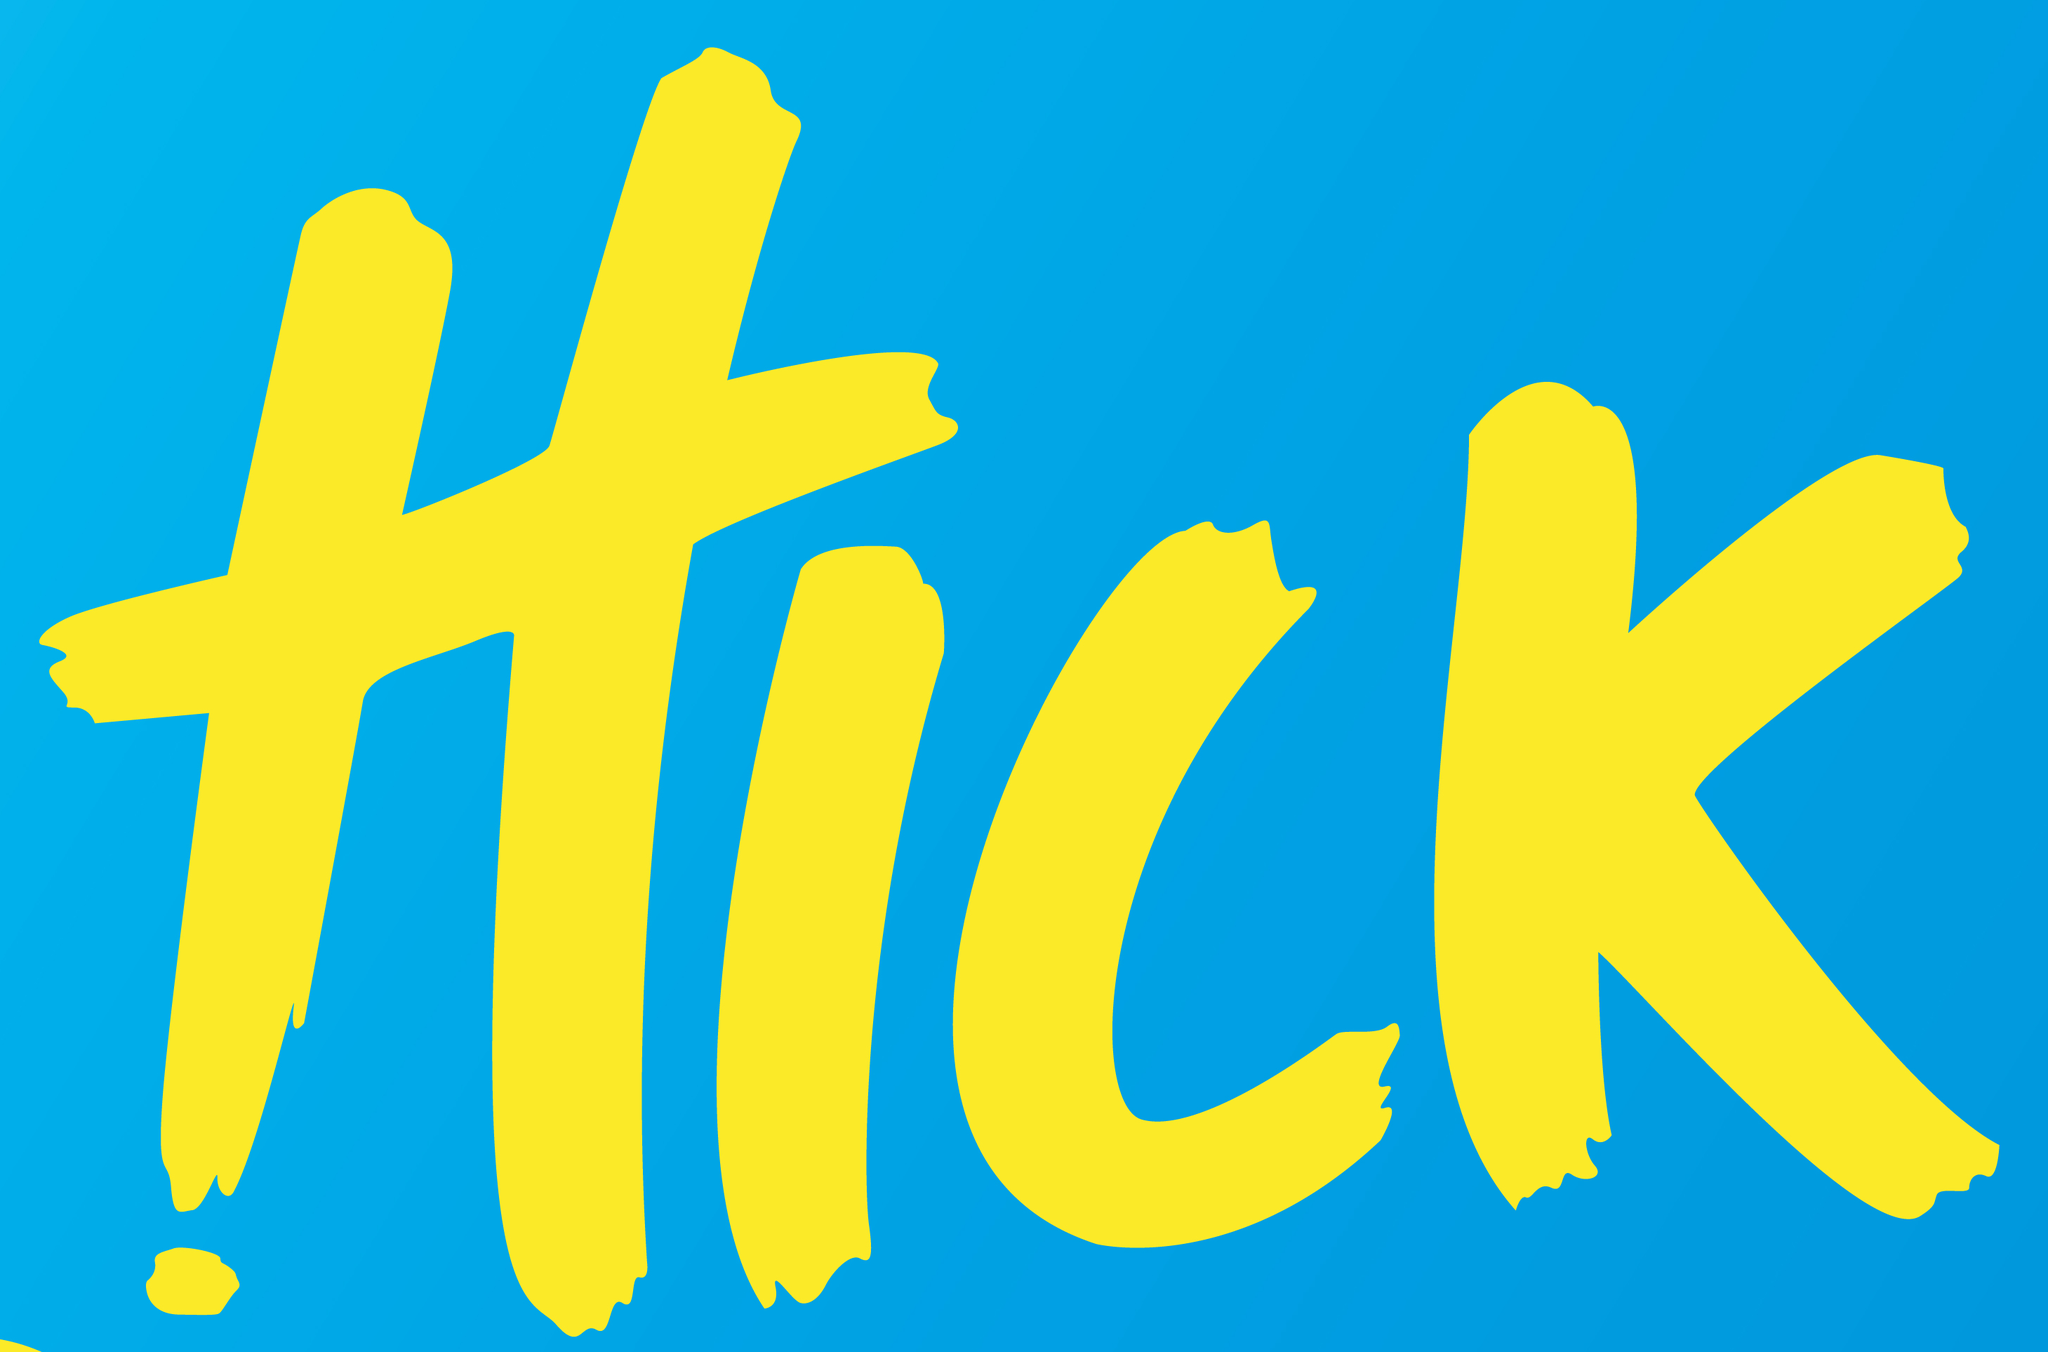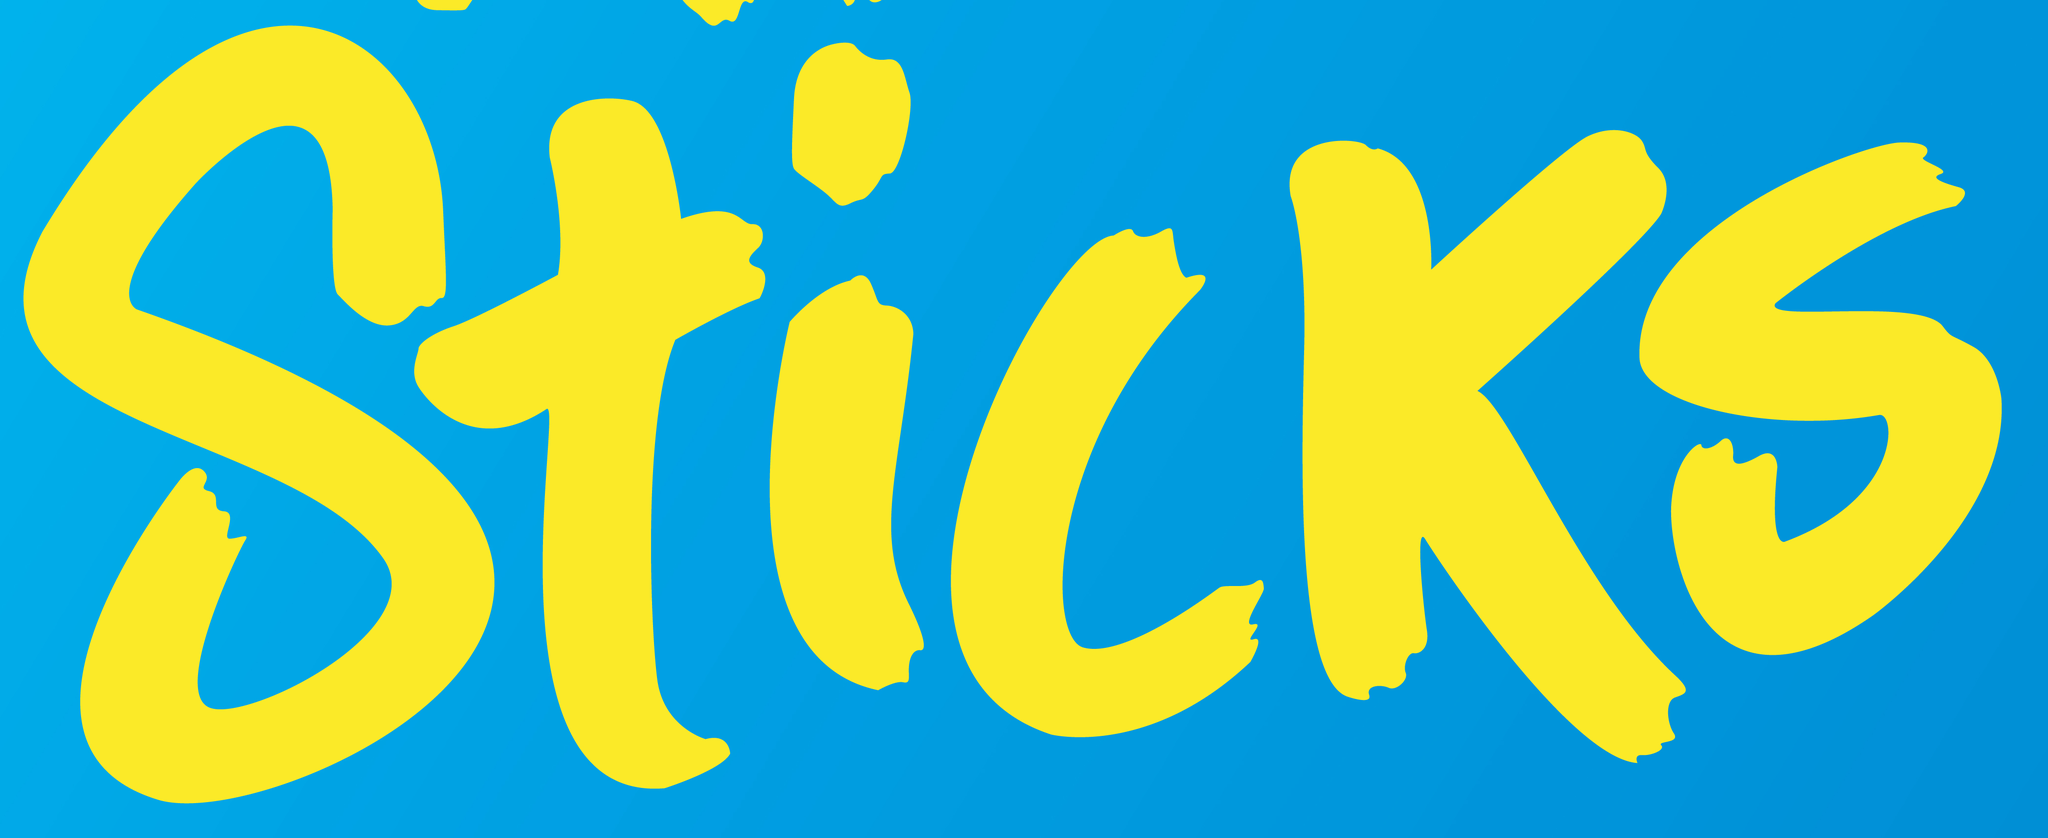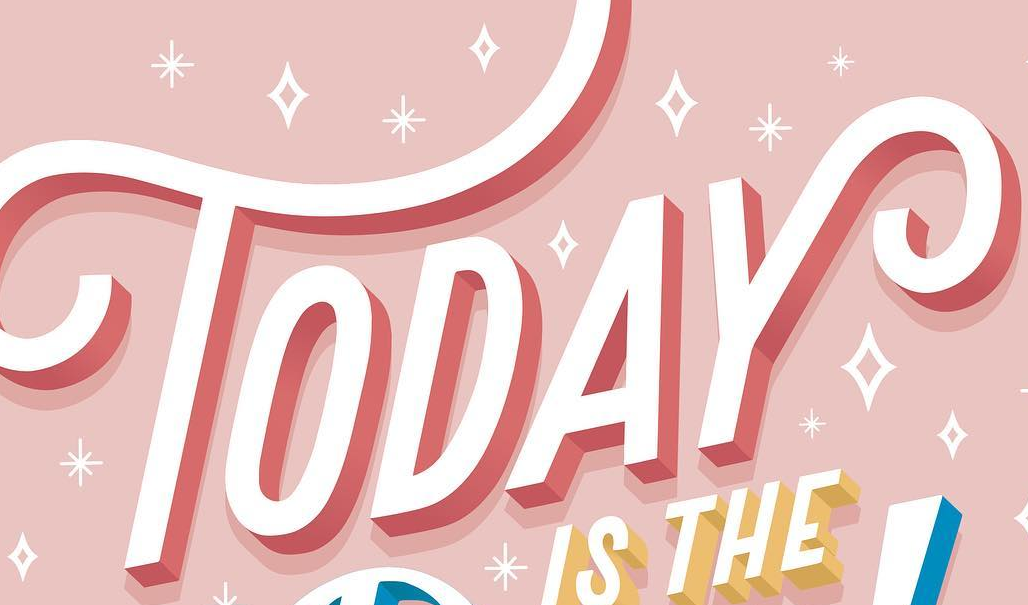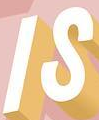What text is displayed in these images sequentially, separated by a semicolon? HICK; Sticks; TODAY; IS 